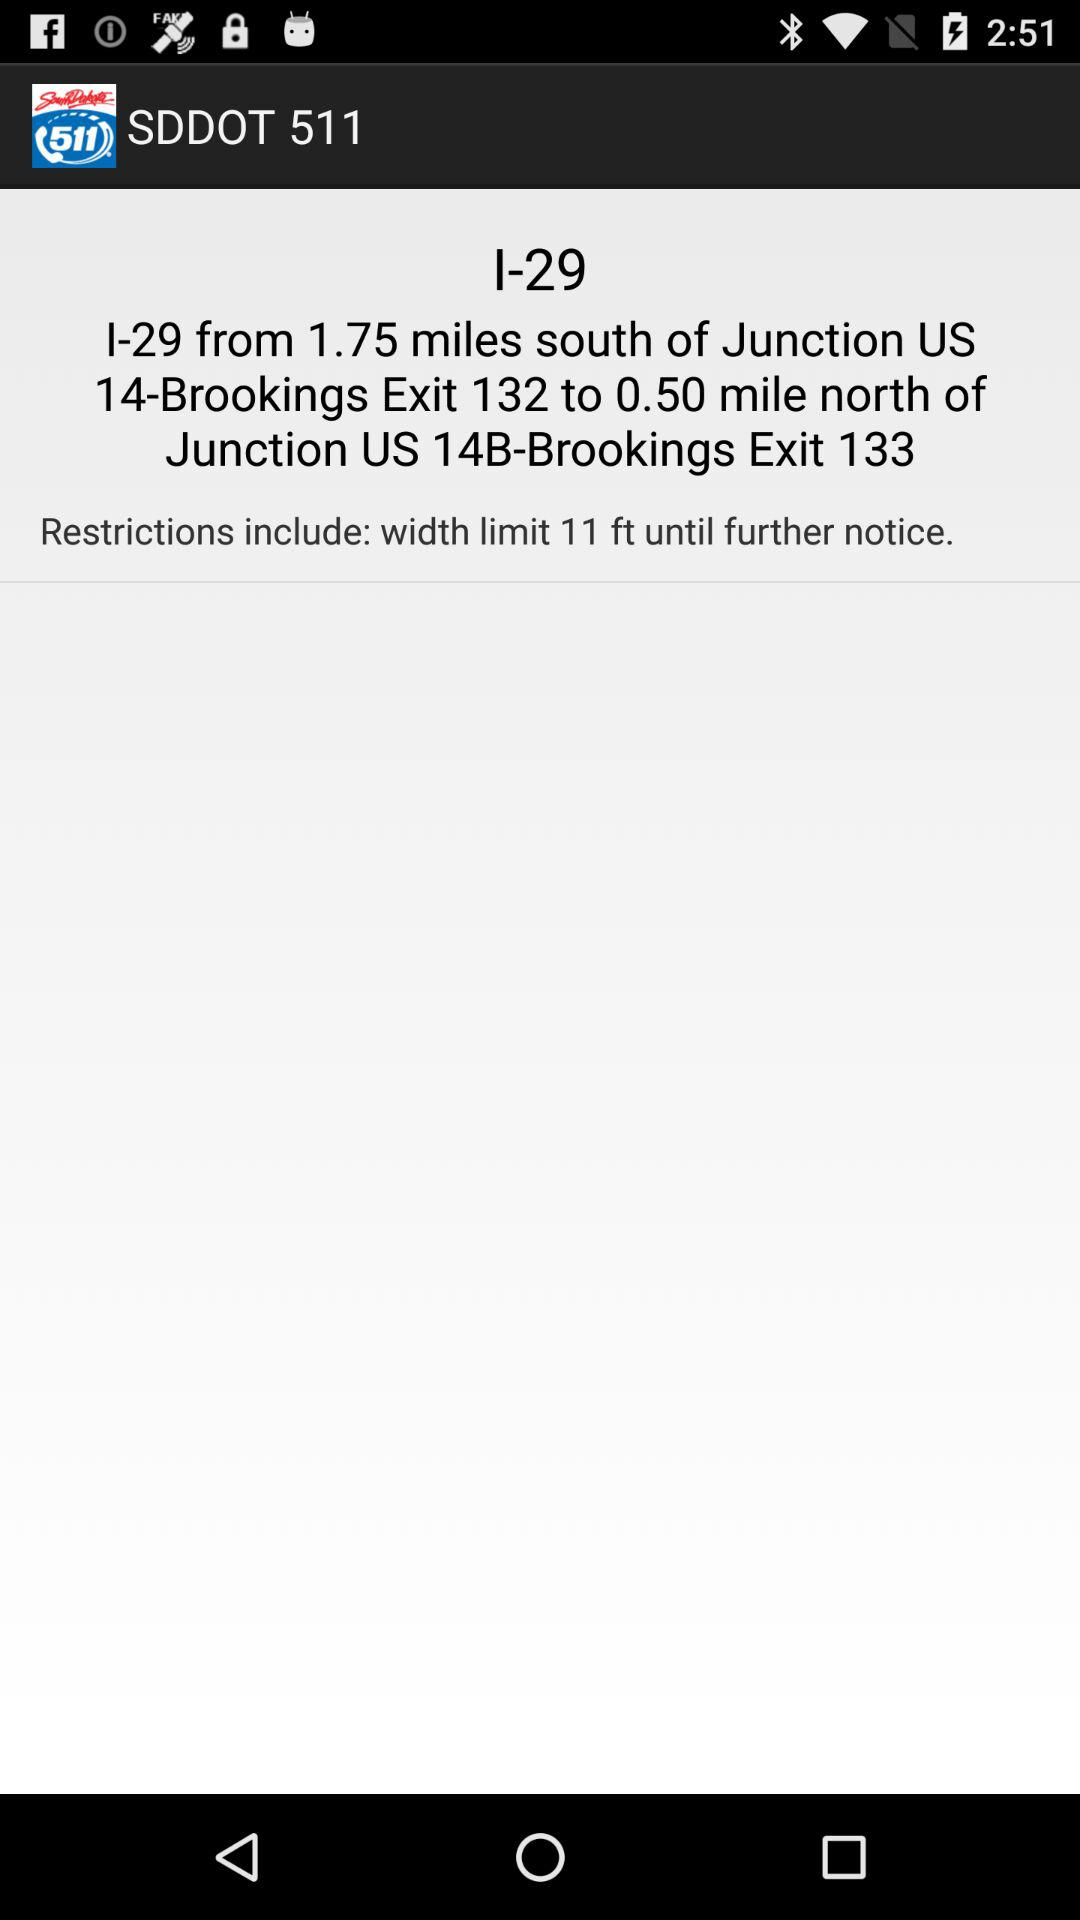How many miles south of Junction US 14-Brookings Exit 132 is the width limit?
Answer the question using a single word or phrase. 1.75 